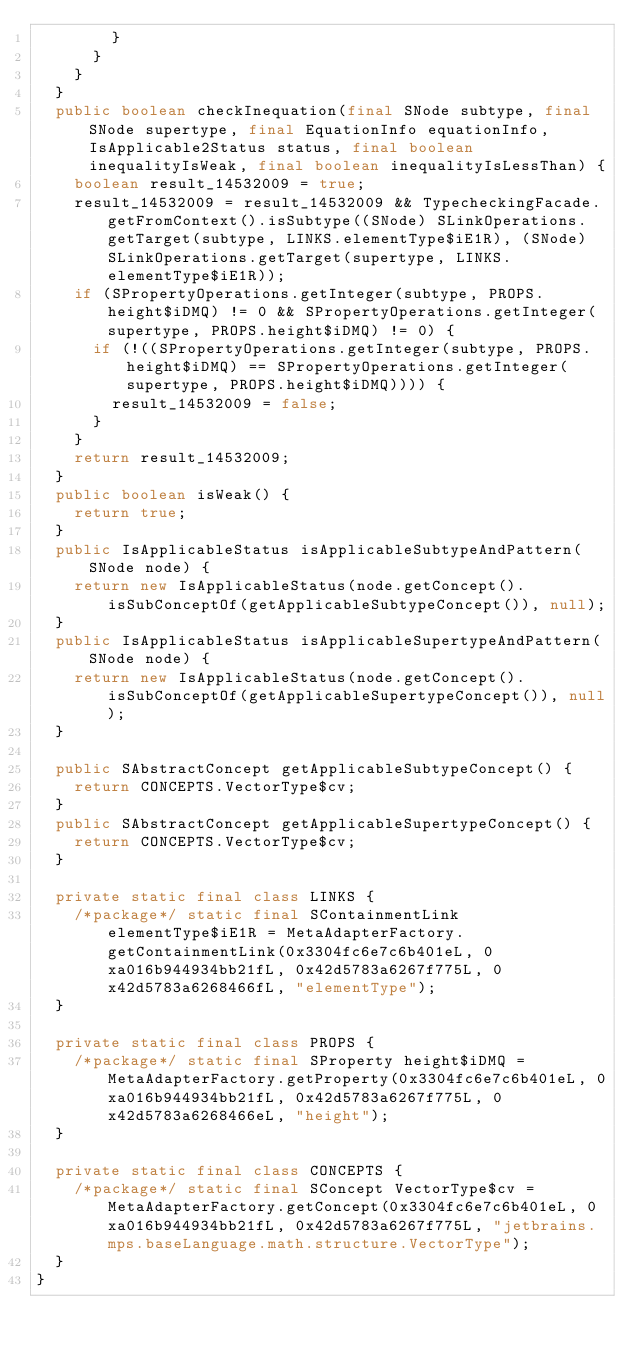Convert code to text. <code><loc_0><loc_0><loc_500><loc_500><_Java_>        }
      }
    }
  }
  public boolean checkInequation(final SNode subtype, final SNode supertype, final EquationInfo equationInfo, IsApplicable2Status status, final boolean inequalityIsWeak, final boolean inequalityIsLessThan) {
    boolean result_14532009 = true;
    result_14532009 = result_14532009 && TypecheckingFacade.getFromContext().isSubtype((SNode) SLinkOperations.getTarget(subtype, LINKS.elementType$iE1R), (SNode) SLinkOperations.getTarget(supertype, LINKS.elementType$iE1R));
    if (SPropertyOperations.getInteger(subtype, PROPS.height$iDMQ) != 0 && SPropertyOperations.getInteger(supertype, PROPS.height$iDMQ) != 0) {
      if (!((SPropertyOperations.getInteger(subtype, PROPS.height$iDMQ) == SPropertyOperations.getInteger(supertype, PROPS.height$iDMQ)))) {
        result_14532009 = false;
      }
    }
    return result_14532009;
  }
  public boolean isWeak() {
    return true;
  }
  public IsApplicableStatus isApplicableSubtypeAndPattern(SNode node) {
    return new IsApplicableStatus(node.getConcept().isSubConceptOf(getApplicableSubtypeConcept()), null);
  }
  public IsApplicableStatus isApplicableSupertypeAndPattern(SNode node) {
    return new IsApplicableStatus(node.getConcept().isSubConceptOf(getApplicableSupertypeConcept()), null);
  }

  public SAbstractConcept getApplicableSubtypeConcept() {
    return CONCEPTS.VectorType$cv;
  }
  public SAbstractConcept getApplicableSupertypeConcept() {
    return CONCEPTS.VectorType$cv;
  }

  private static final class LINKS {
    /*package*/ static final SContainmentLink elementType$iE1R = MetaAdapterFactory.getContainmentLink(0x3304fc6e7c6b401eL, 0xa016b944934bb21fL, 0x42d5783a6267f775L, 0x42d5783a6268466fL, "elementType");
  }

  private static final class PROPS {
    /*package*/ static final SProperty height$iDMQ = MetaAdapterFactory.getProperty(0x3304fc6e7c6b401eL, 0xa016b944934bb21fL, 0x42d5783a6267f775L, 0x42d5783a6268466eL, "height");
  }

  private static final class CONCEPTS {
    /*package*/ static final SConcept VectorType$cv = MetaAdapterFactory.getConcept(0x3304fc6e7c6b401eL, 0xa016b944934bb21fL, 0x42d5783a6267f775L, "jetbrains.mps.baseLanguage.math.structure.VectorType");
  }
}
</code> 